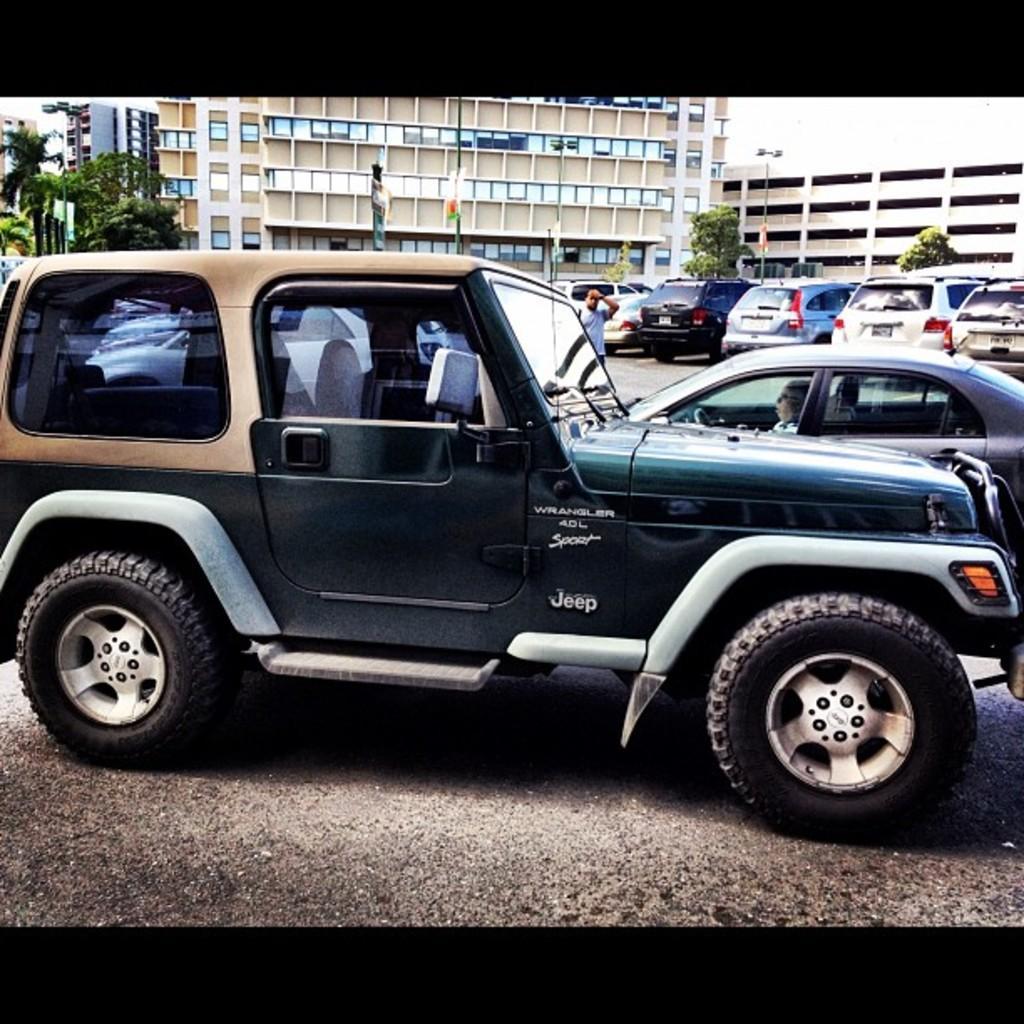Please provide a concise description of this image. In this picture we can see vehicles and a person on the road. Behind the vehicles, there are poles, trees and buildings. 